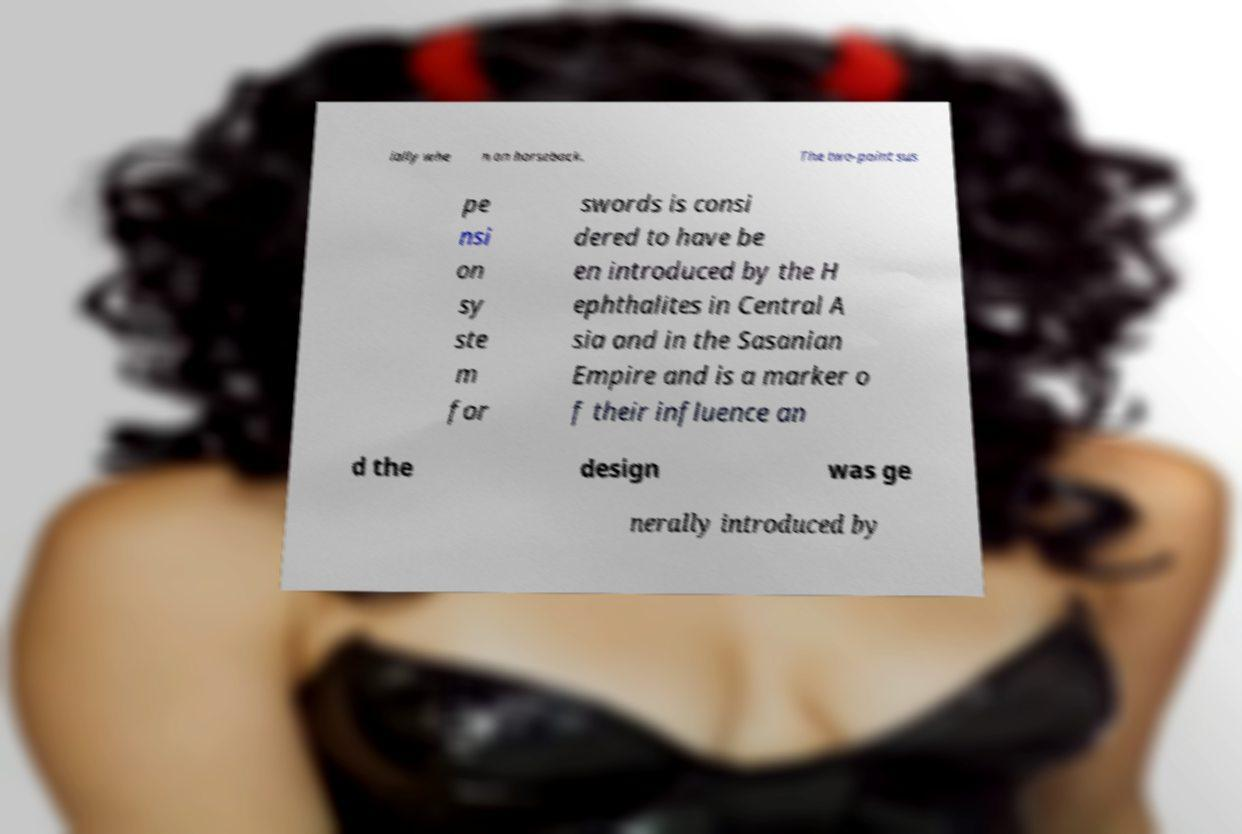Could you assist in decoding the text presented in this image and type it out clearly? ially whe n on horseback. The two-point sus pe nsi on sy ste m for swords is consi dered to have be en introduced by the H ephthalites in Central A sia and in the Sasanian Empire and is a marker o f their influence an d the design was ge nerally introduced by 